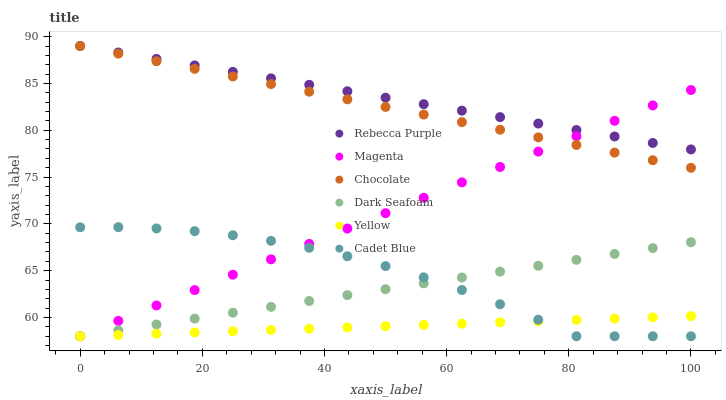Does Yellow have the minimum area under the curve?
Answer yes or no. Yes. Does Rebecca Purple have the maximum area under the curve?
Answer yes or no. Yes. Does Chocolate have the minimum area under the curve?
Answer yes or no. No. Does Chocolate have the maximum area under the curve?
Answer yes or no. No. Is Magenta the smoothest?
Answer yes or no. Yes. Is Cadet Blue the roughest?
Answer yes or no. Yes. Is Yellow the smoothest?
Answer yes or no. No. Is Yellow the roughest?
Answer yes or no. No. Does Cadet Blue have the lowest value?
Answer yes or no. Yes. Does Chocolate have the lowest value?
Answer yes or no. No. Does Rebecca Purple have the highest value?
Answer yes or no. Yes. Does Yellow have the highest value?
Answer yes or no. No. Is Cadet Blue less than Rebecca Purple?
Answer yes or no. Yes. Is Rebecca Purple greater than Cadet Blue?
Answer yes or no. Yes. Does Magenta intersect Yellow?
Answer yes or no. Yes. Is Magenta less than Yellow?
Answer yes or no. No. Is Magenta greater than Yellow?
Answer yes or no. No. Does Cadet Blue intersect Rebecca Purple?
Answer yes or no. No. 